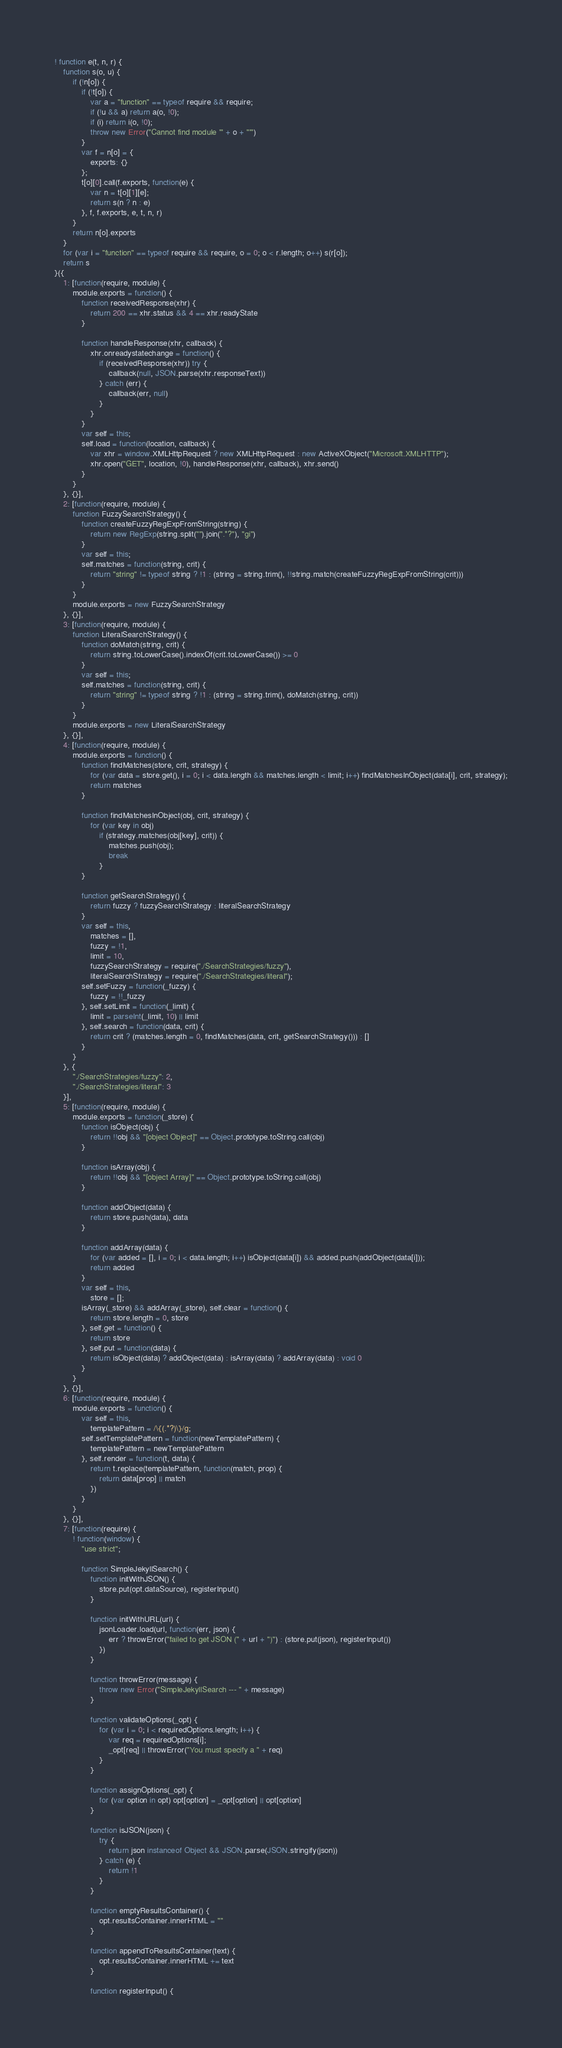Convert code to text. <code><loc_0><loc_0><loc_500><loc_500><_JavaScript_>! function e(t, n, r) {
    function s(o, u) {
        if (!n[o]) {
            if (!t[o]) {
                var a = "function" == typeof require && require;
                if (!u && a) return a(o, !0);
                if (i) return i(o, !0);
                throw new Error("Cannot find module '" + o + "'")
            }
            var f = n[o] = {
                exports: {}
            };
            t[o][0].call(f.exports, function(e) {
                var n = t[o][1][e];
                return s(n ? n : e)
            }, f, f.exports, e, t, n, r)
        }
        return n[o].exports
    }
    for (var i = "function" == typeof require && require, o = 0; o < r.length; o++) s(r[o]);
    return s
}({
    1: [function(require, module) {
        module.exports = function() {
            function receivedResponse(xhr) {
                return 200 == xhr.status && 4 == xhr.readyState
            }

            function handleResponse(xhr, callback) {
                xhr.onreadystatechange = function() {
                    if (receivedResponse(xhr)) try {
                        callback(null, JSON.parse(xhr.responseText))
                    } catch (err) {
                        callback(err, null)
                    }
                }
            }
            var self = this;
            self.load = function(location, callback) {
                var xhr = window.XMLHttpRequest ? new XMLHttpRequest : new ActiveXObject("Microsoft.XMLHTTP");
                xhr.open("GET", location, !0), handleResponse(xhr, callback), xhr.send()
            }
        }
    }, {}],
    2: [function(require, module) {
        function FuzzySearchStrategy() {
            function createFuzzyRegExpFromString(string) {
                return new RegExp(string.split("").join(".*?"), "gi")
            }
            var self = this;
            self.matches = function(string, crit) {
                return "string" != typeof string ? !1 : (string = string.trim(), !!string.match(createFuzzyRegExpFromString(crit)))
            }
        }
        module.exports = new FuzzySearchStrategy
    }, {}],
    3: [function(require, module) {
        function LiteralSearchStrategy() {
            function doMatch(string, crit) {
                return string.toLowerCase().indexOf(crit.toLowerCase()) >= 0
            }
            var self = this;
            self.matches = function(string, crit) {
                return "string" != typeof string ? !1 : (string = string.trim(), doMatch(string, crit))
            }
        }
        module.exports = new LiteralSearchStrategy
    }, {}],
    4: [function(require, module) {
        module.exports = function() {
            function findMatches(store, crit, strategy) {
                for (var data = store.get(), i = 0; i < data.length && matches.length < limit; i++) findMatchesInObject(data[i], crit, strategy);
                return matches
            }

            function findMatchesInObject(obj, crit, strategy) {
                for (var key in obj)
                    if (strategy.matches(obj[key], crit)) {
                        matches.push(obj);
                        break
                    }
            }

            function getSearchStrategy() {
                return fuzzy ? fuzzySearchStrategy : literalSearchStrategy
            }
            var self = this,
                matches = [],
                fuzzy = !1,
                limit = 10,
                fuzzySearchStrategy = require("./SearchStrategies/fuzzy"),
                literalSearchStrategy = require("./SearchStrategies/literal");
            self.setFuzzy = function(_fuzzy) {
                fuzzy = !!_fuzzy
            }, self.setLimit = function(_limit) {
                limit = parseInt(_limit, 10) || limit
            }, self.search = function(data, crit) {
                return crit ? (matches.length = 0, findMatches(data, crit, getSearchStrategy())) : []
            }
        }
    }, {
        "./SearchStrategies/fuzzy": 2,
        "./SearchStrategies/literal": 3
    }],
    5: [function(require, module) {
        module.exports = function(_store) {
            function isObject(obj) {
                return !!obj && "[object Object]" == Object.prototype.toString.call(obj)
            }

            function isArray(obj) {
                return !!obj && "[object Array]" == Object.prototype.toString.call(obj)
            }

            function addObject(data) {
                return store.push(data), data
            }

            function addArray(data) {
                for (var added = [], i = 0; i < data.length; i++) isObject(data[i]) && added.push(addObject(data[i]));
                return added
            }
            var self = this,
                store = [];
            isArray(_store) && addArray(_store), self.clear = function() {
                return store.length = 0, store
            }, self.get = function() {
                return store
            }, self.put = function(data) {
                return isObject(data) ? addObject(data) : isArray(data) ? addArray(data) : void 0
            }
        }
    }, {}],
    6: [function(require, module) {
        module.exports = function() {
            var self = this,
                templatePattern = /\{(.*?)\}/g;
            self.setTemplatePattern = function(newTemplatePattern) {
                templatePattern = newTemplatePattern
            }, self.render = function(t, data) {
                return t.replace(templatePattern, function(match, prop) {
                    return data[prop] || match
                })
            }
        }
    }, {}],
    7: [function(require) {
        ! function(window) {
            "use strict";

            function SimpleJekyllSearch() {
                function initWithJSON() {
                    store.put(opt.dataSource), registerInput()
                }

                function initWithURL(url) {
                    jsonLoader.load(url, function(err, json) {
                        err ? throwError("failed to get JSON (" + url + ")") : (store.put(json), registerInput())
                    })
                }

                function throwError(message) {
                    throw new Error("SimpleJekyllSearch --- " + message)
                }

                function validateOptions(_opt) {
                    for (var i = 0; i < requiredOptions.length; i++) {
                        var req = requiredOptions[i];
                        _opt[req] || throwError("You must specify a " + req)
                    }
                }

                function assignOptions(_opt) {
                    for (var option in opt) opt[option] = _opt[option] || opt[option]
                }

                function isJSON(json) {
                    try {
                        return json instanceof Object && JSON.parse(JSON.stringify(json))
                    } catch (e) {
                        return !1
                    }
                }

                function emptyResultsContainer() {
                    opt.resultsContainer.innerHTML = ""
                }

                function appendToResultsContainer(text) {
                    opt.resultsContainer.innerHTML += text
                }

                function registerInput() {</code> 